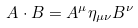Convert formula to latex. <formula><loc_0><loc_0><loc_500><loc_500>A \cdot B = A ^ { \mu } \eta _ { \mu \nu } B ^ { \nu }</formula> 